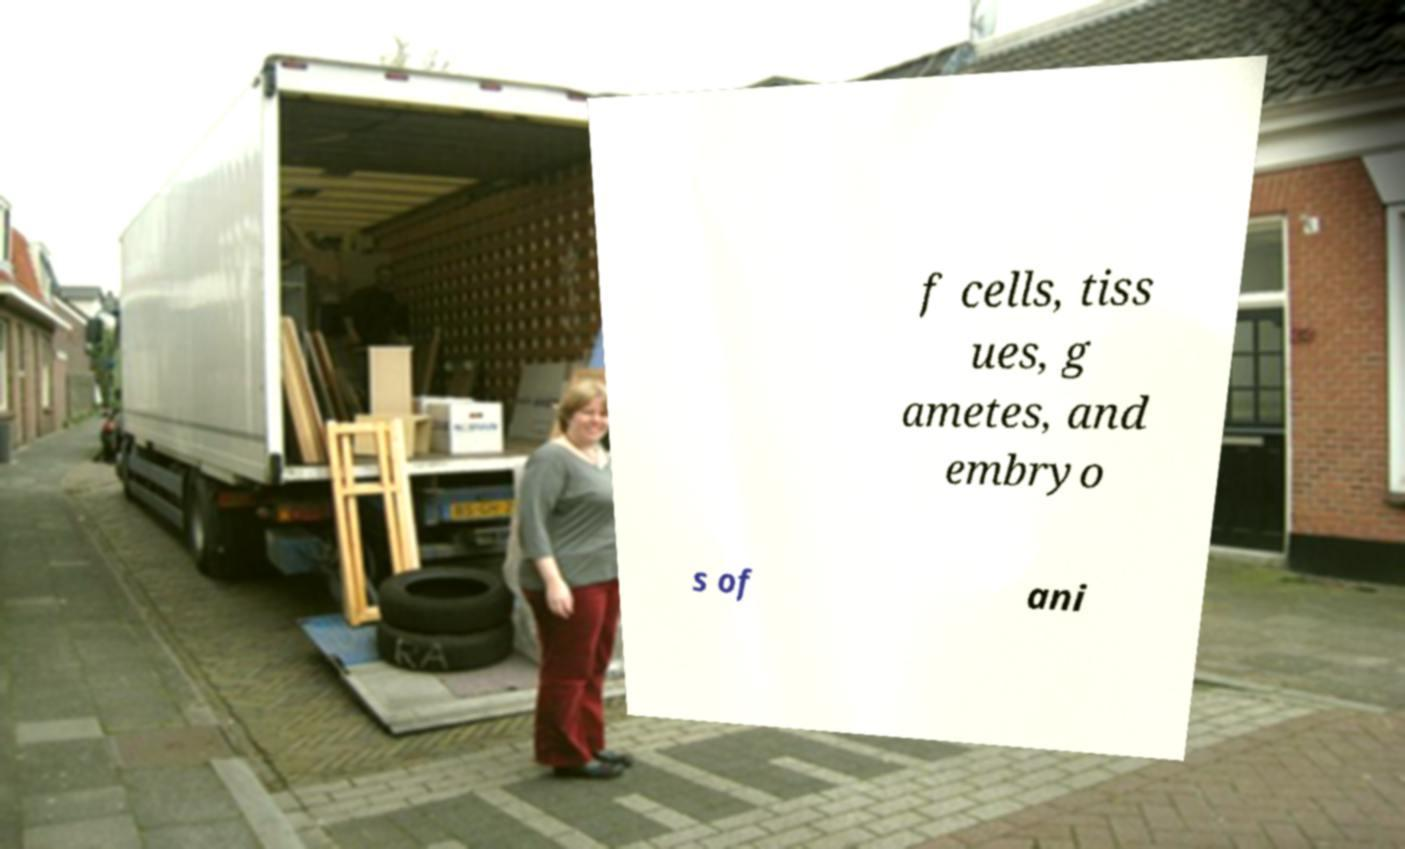For documentation purposes, I need the text within this image transcribed. Could you provide that? f cells, tiss ues, g ametes, and embryo s of ani 